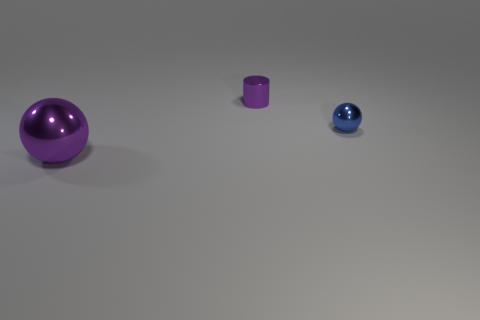Is there any other thing that has the same shape as the small purple shiny thing?
Offer a terse response. No. What number of blue things are the same size as the shiny cylinder?
Ensure brevity in your answer.  1. What size is the thing that is the same color as the large sphere?
Ensure brevity in your answer.  Small. Is the color of the shiny cylinder the same as the large sphere?
Provide a short and direct response. Yes. The small purple shiny thing is what shape?
Offer a very short reply. Cylinder. Are there any other small metal cylinders that have the same color as the tiny metallic cylinder?
Offer a very short reply. No. Are there more large metallic balls in front of the small blue sphere than large gray cubes?
Give a very brief answer. Yes. Is the shape of the tiny blue shiny object the same as the tiny object that is to the left of the tiny blue object?
Provide a succinct answer. No. Are there any large metallic things?
Provide a short and direct response. Yes. What number of large objects are either gray metal spheres or blue metallic balls?
Your answer should be compact. 0. 